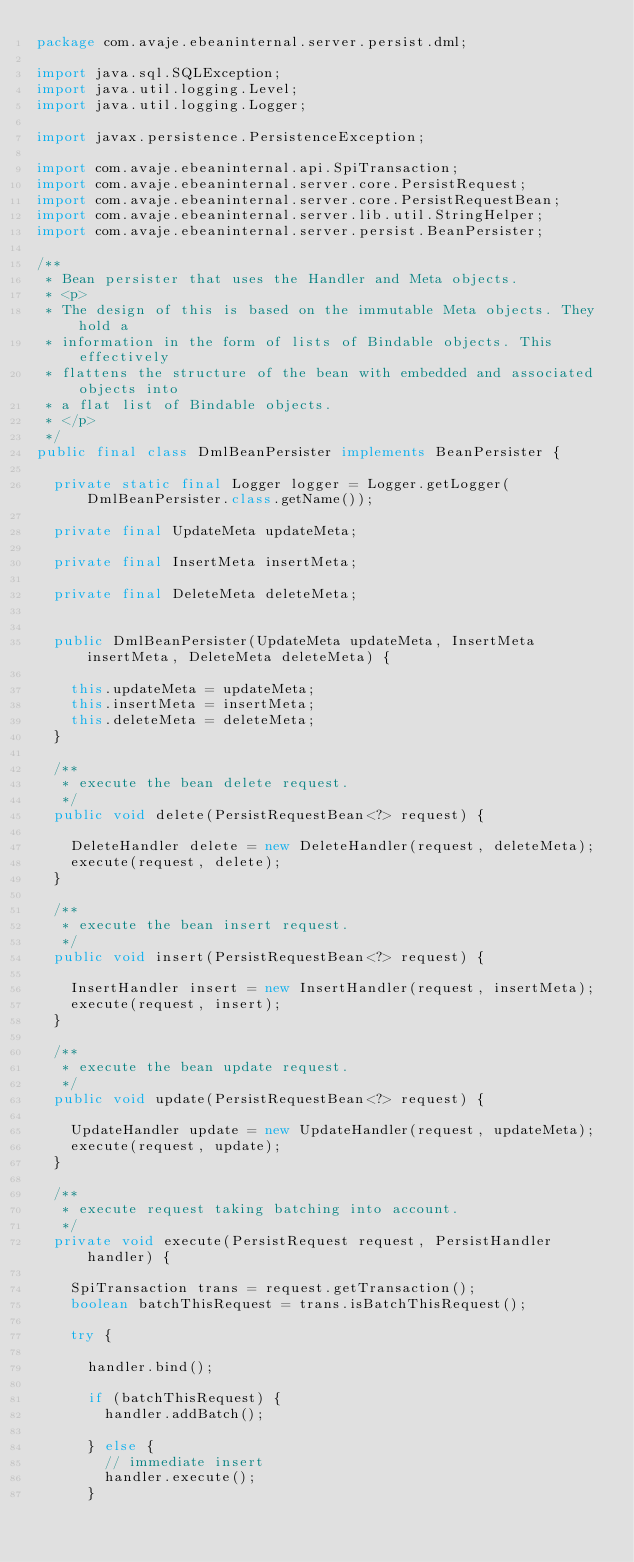<code> <loc_0><loc_0><loc_500><loc_500><_Java_>package com.avaje.ebeaninternal.server.persist.dml;

import java.sql.SQLException;
import java.util.logging.Level;
import java.util.logging.Logger;

import javax.persistence.PersistenceException;

import com.avaje.ebeaninternal.api.SpiTransaction;
import com.avaje.ebeaninternal.server.core.PersistRequest;
import com.avaje.ebeaninternal.server.core.PersistRequestBean;
import com.avaje.ebeaninternal.server.lib.util.StringHelper;
import com.avaje.ebeaninternal.server.persist.BeanPersister;

/**
 * Bean persister that uses the Handler and Meta objects.
 * <p>
 * The design of this is based on the immutable Meta objects. They hold a
 * information in the form of lists of Bindable objects. This effectively
 * flattens the structure of the bean with embedded and associated objects into
 * a flat list of Bindable objects.
 * </p>
 */
public final class DmlBeanPersister implements BeanPersister {

	private static final Logger logger = Logger.getLogger(DmlBeanPersister.class.getName());

	private final UpdateMeta updateMeta;

	private final InsertMeta insertMeta;

	private final DeleteMeta deleteMeta;

	
	public DmlBeanPersister(UpdateMeta updateMeta, InsertMeta insertMeta, DeleteMeta deleteMeta) {

		this.updateMeta = updateMeta;
		this.insertMeta = insertMeta;
		this.deleteMeta = deleteMeta;
	}

	/**
	 * execute the bean delete request.
	 */
	public void delete(PersistRequestBean<?> request) {

		DeleteHandler delete = new DeleteHandler(request, deleteMeta);
		execute(request, delete);
	}

	/**
	 * execute the bean insert request.
	 */
	public void insert(PersistRequestBean<?> request) {

		InsertHandler insert = new InsertHandler(request, insertMeta);
		execute(request, insert);
	}

	/**
	 * execute the bean update request.
	 */
	public void update(PersistRequestBean<?> request) {

		UpdateHandler update = new UpdateHandler(request, updateMeta);
		execute(request, update);
	}

	/**
	 * execute request taking batching into account.
	 */
	private void execute(PersistRequest request, PersistHandler handler) {

		SpiTransaction trans = request.getTransaction();
		boolean batchThisRequest = trans.isBatchThisRequest();

		try {

			handler.bind();

			if (batchThisRequest) {
				handler.addBatch();

			} else {
				// immediate insert
				handler.execute();
			}
</code> 